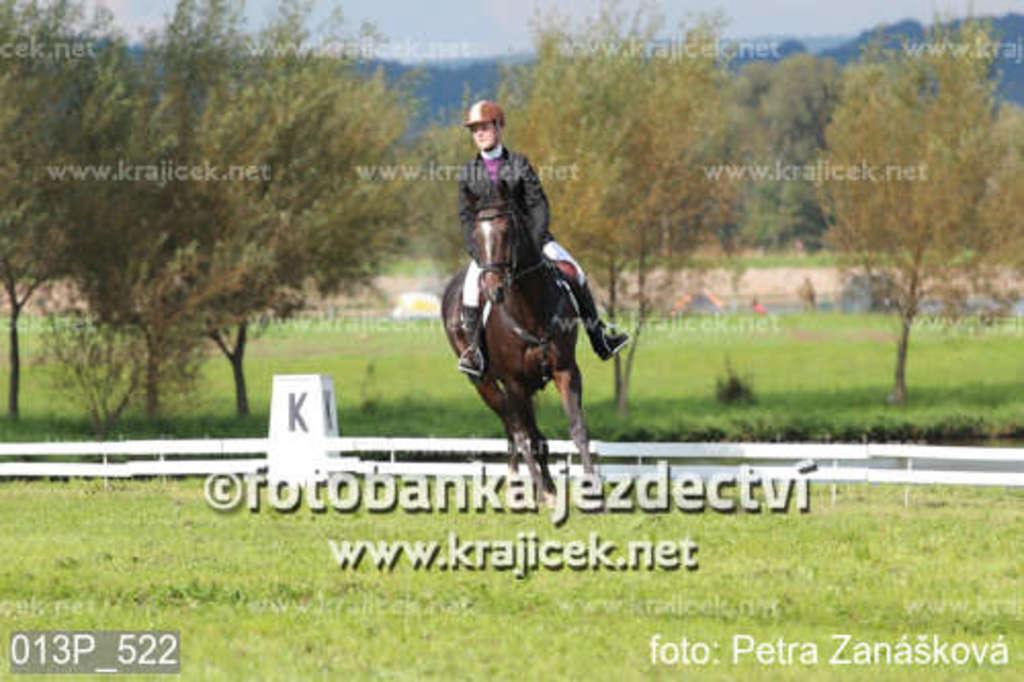How would you summarize this image in a sentence or two? In this image there is a man who is riding the horse on the ground. In the background there are trees. At the bottom there is a wooden fence behind the horse. On the ground there is grass. 